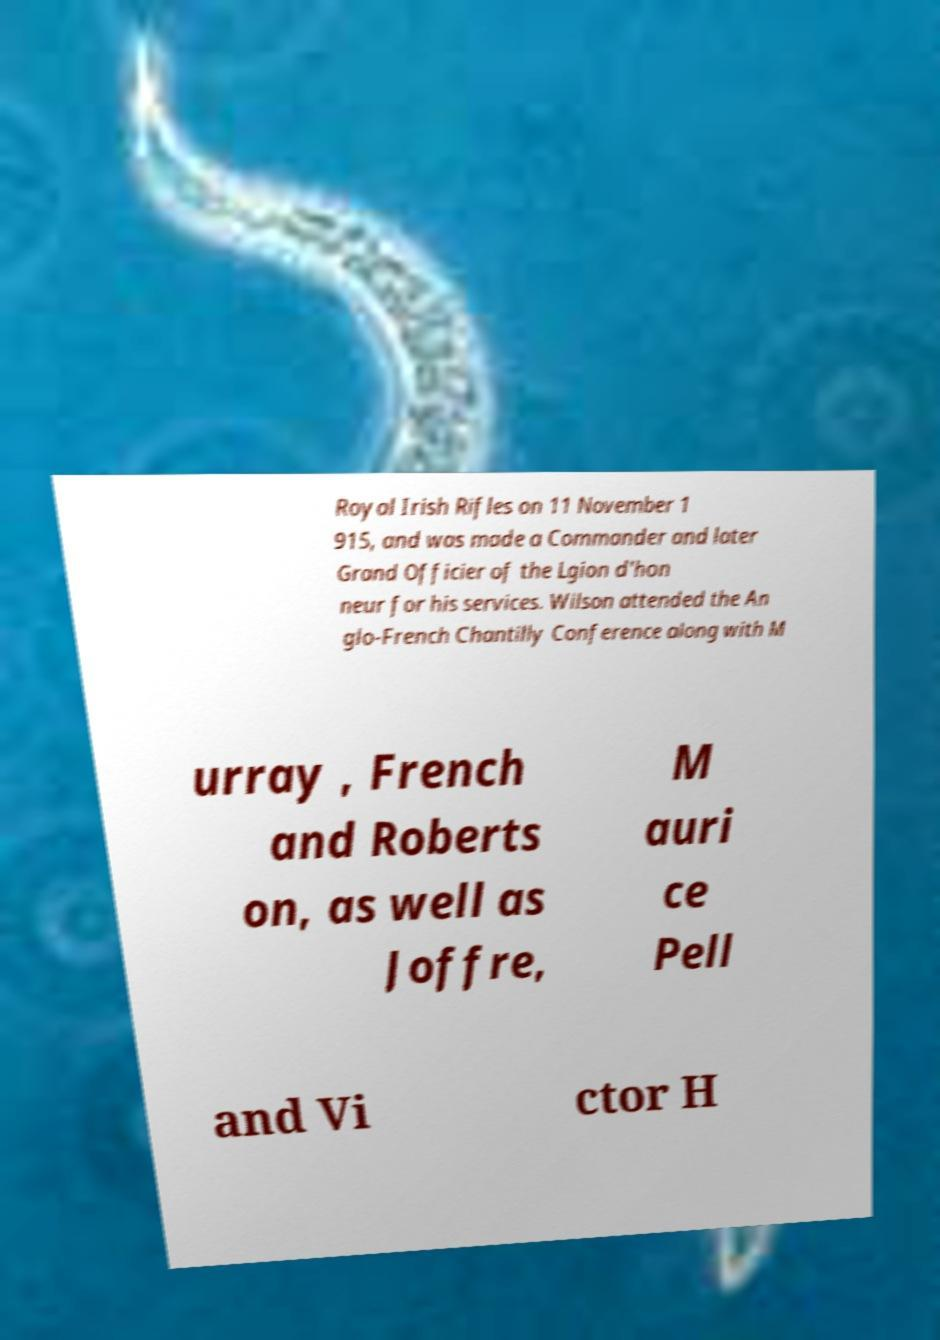Could you extract and type out the text from this image? Royal Irish Rifles on 11 November 1 915, and was made a Commander and later Grand Officier of the Lgion d'hon neur for his services. Wilson attended the An glo-French Chantilly Conference along with M urray , French and Roberts on, as well as Joffre, M auri ce Pell and Vi ctor H 